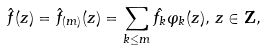<formula> <loc_0><loc_0><loc_500><loc_500>\hat { f } ( z ) = \hat { f } _ { ( m ) } ( z ) = \sum _ { k \leq m } \hat { f _ { k } } \varphi _ { k } ( z ) , \, z \in \mathbf Z ,</formula> 